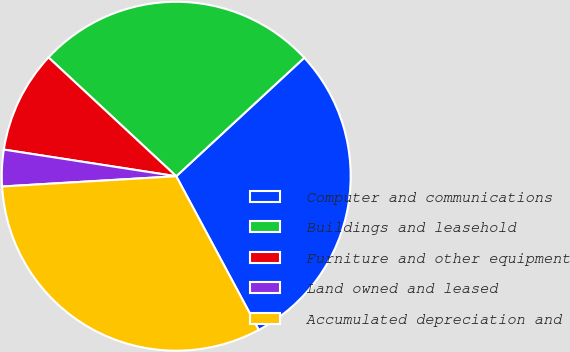<chart> <loc_0><loc_0><loc_500><loc_500><pie_chart><fcel>Computer and communications<fcel>Buildings and leasehold<fcel>Furniture and other equipment<fcel>Land owned and leased<fcel>Accumulated depreciation and<nl><fcel>29.04%<fcel>26.19%<fcel>9.48%<fcel>3.38%<fcel>31.9%<nl></chart> 